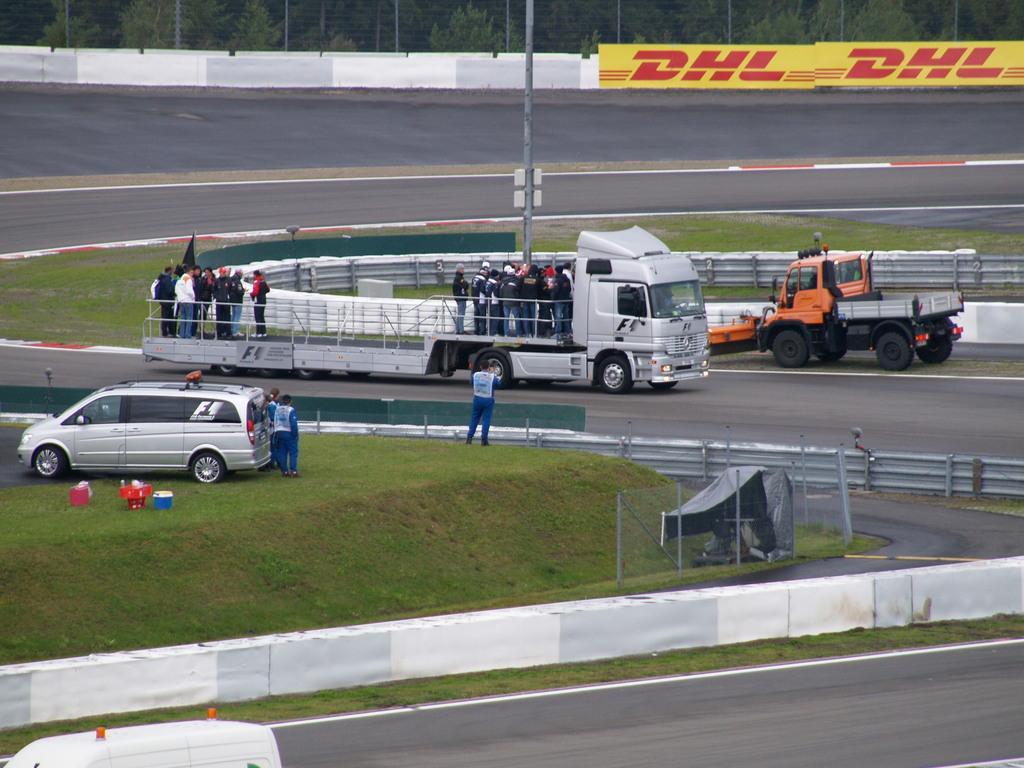Please provide a concise description of this image. In this image there are vehicles on the road and there are people. At the bottom there is a road. In the background there is a pole, fence and trees. 